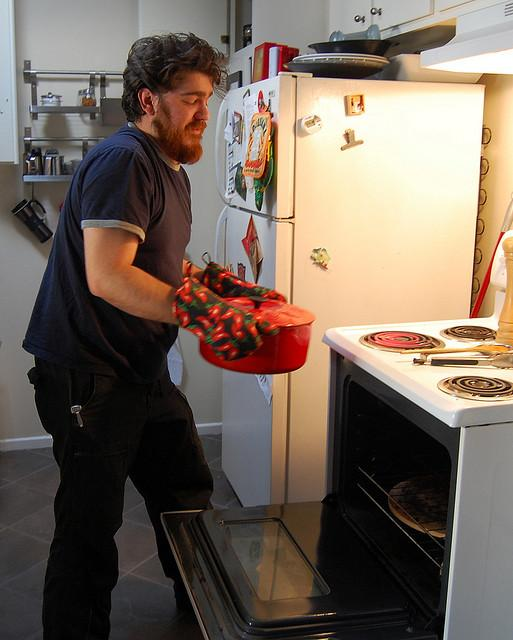What allows him to see the contents of the oven when the door is closed? window 